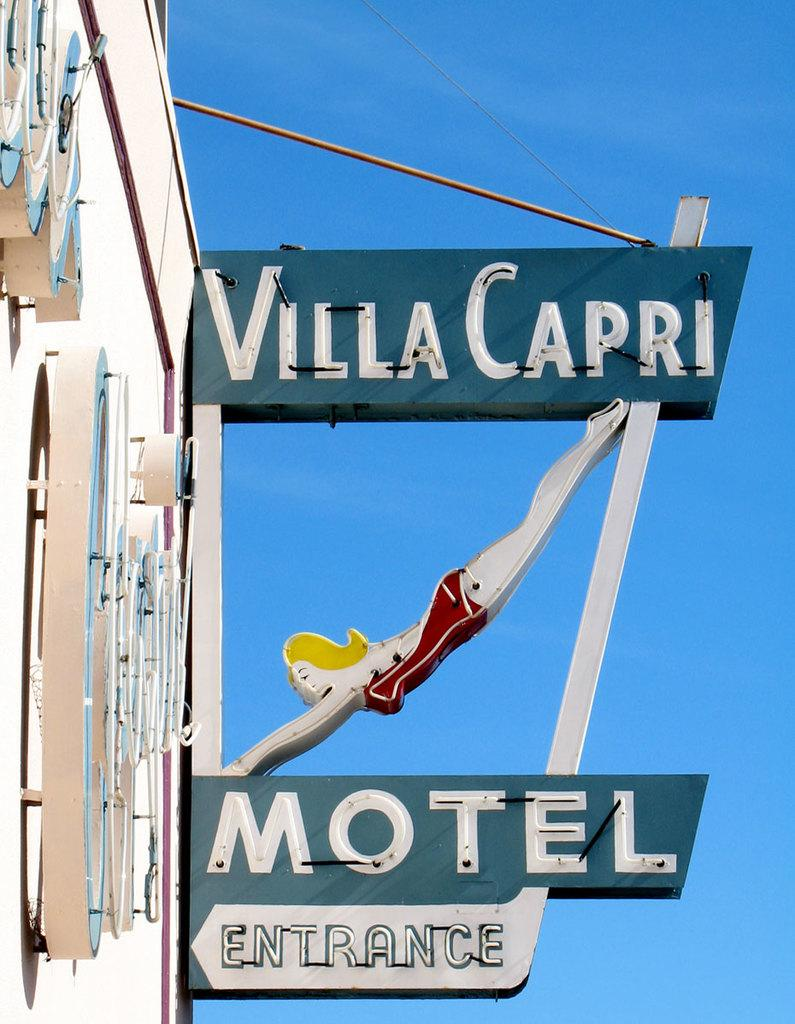<image>
Offer a succinct explanation of the picture presented. The Villa Capri Motel Entrance sign has a woman in a bathing suit that looks like she is diving on it. 